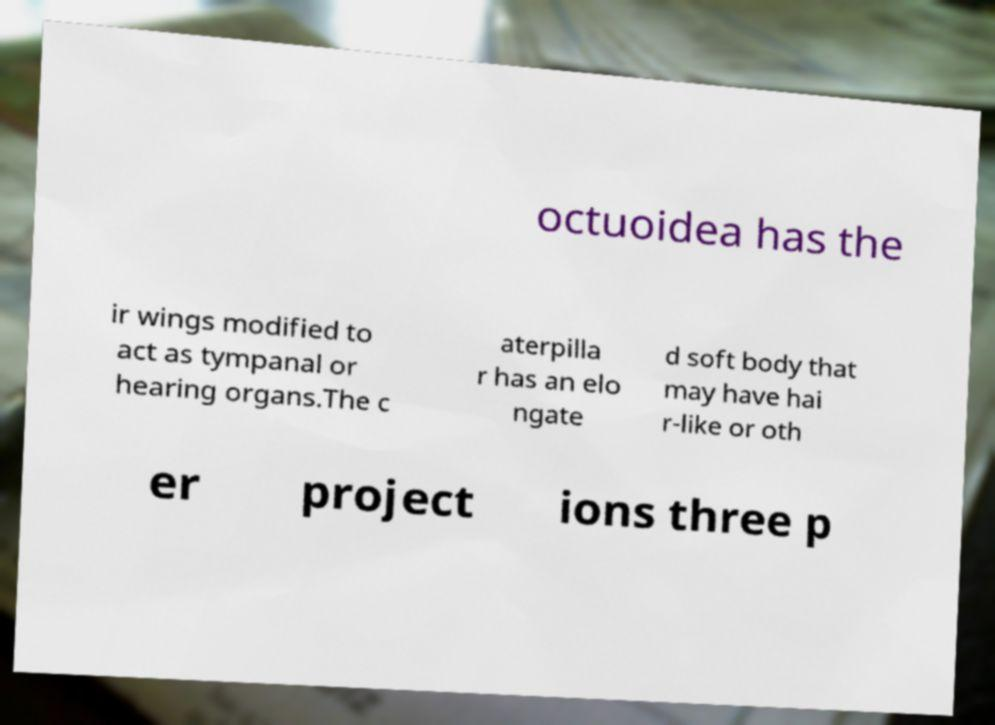There's text embedded in this image that I need extracted. Can you transcribe it verbatim? octuoidea has the ir wings modified to act as tympanal or hearing organs.The c aterpilla r has an elo ngate d soft body that may have hai r-like or oth er project ions three p 